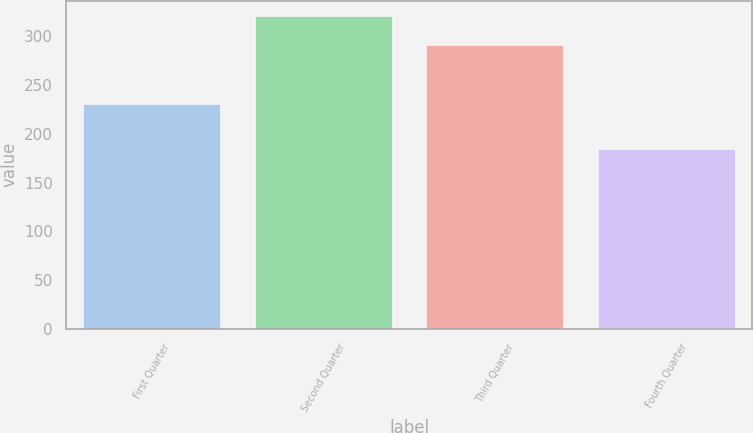Convert chart to OTSL. <chart><loc_0><loc_0><loc_500><loc_500><bar_chart><fcel>First Quarter<fcel>Second Quarter<fcel>Third Quarter<fcel>Fourth Quarter<nl><fcel>230.35<fcel>320.3<fcel>290.96<fcel>184.3<nl></chart> 